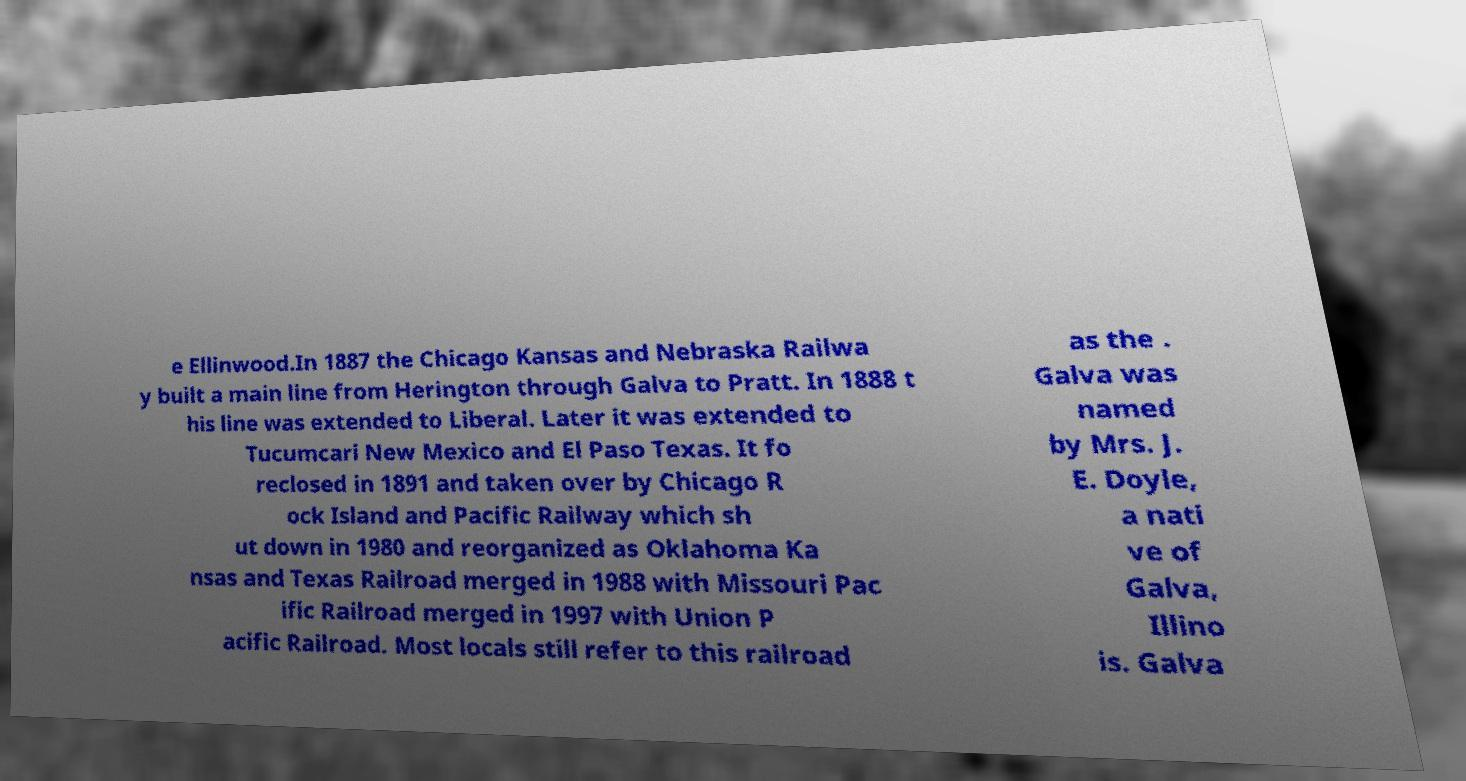What messages or text are displayed in this image? I need them in a readable, typed format. e Ellinwood.In 1887 the Chicago Kansas and Nebraska Railwa y built a main line from Herington through Galva to Pratt. In 1888 t his line was extended to Liberal. Later it was extended to Tucumcari New Mexico and El Paso Texas. It fo reclosed in 1891 and taken over by Chicago R ock Island and Pacific Railway which sh ut down in 1980 and reorganized as Oklahoma Ka nsas and Texas Railroad merged in 1988 with Missouri Pac ific Railroad merged in 1997 with Union P acific Railroad. Most locals still refer to this railroad as the . Galva was named by Mrs. J. E. Doyle, a nati ve of Galva, Illino is. Galva 